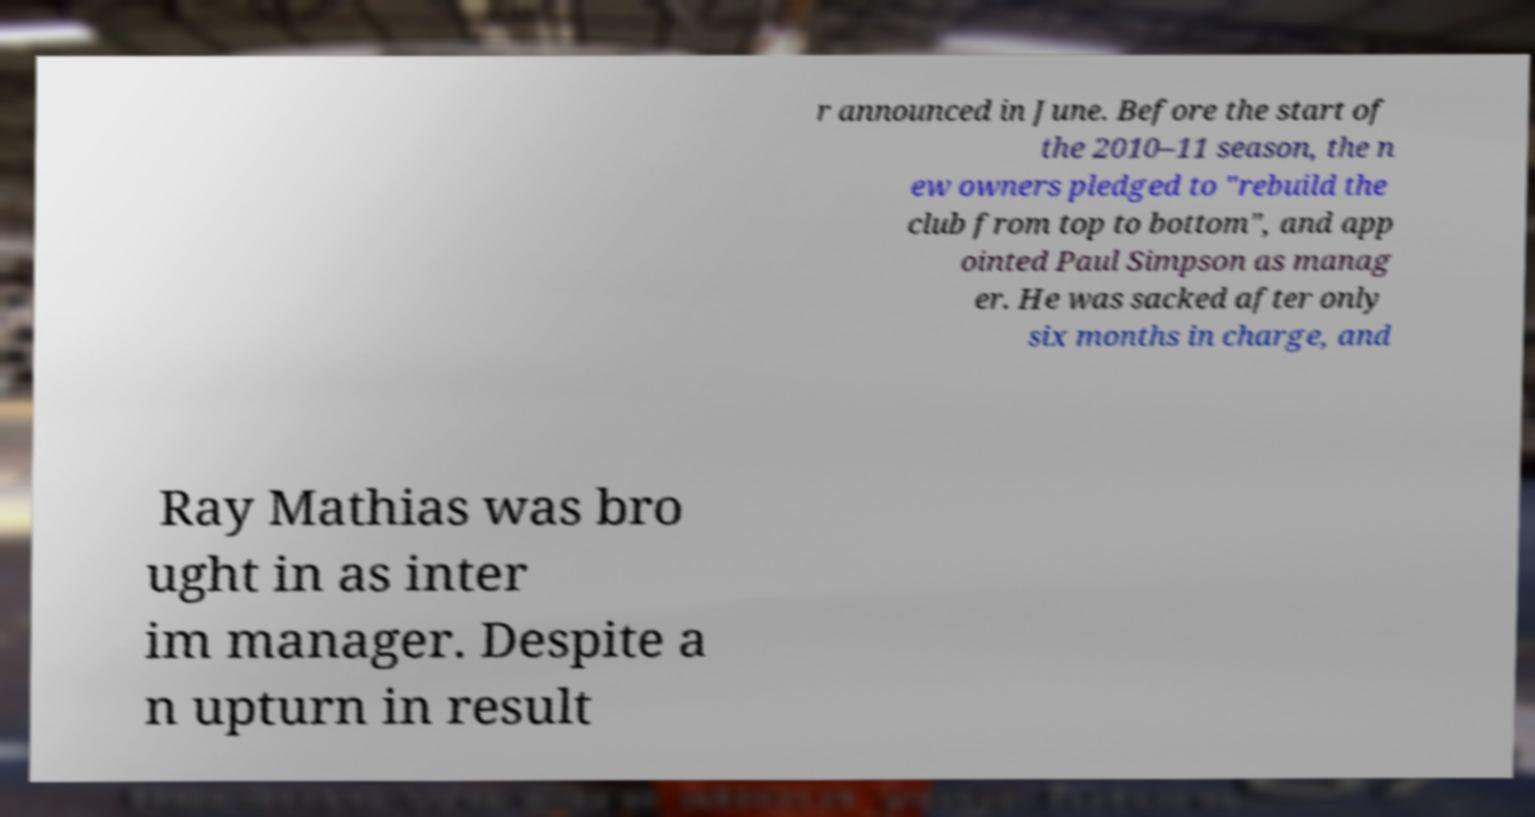Could you extract and type out the text from this image? r announced in June. Before the start of the 2010–11 season, the n ew owners pledged to "rebuild the club from top to bottom", and app ointed Paul Simpson as manag er. He was sacked after only six months in charge, and Ray Mathias was bro ught in as inter im manager. Despite a n upturn in result 